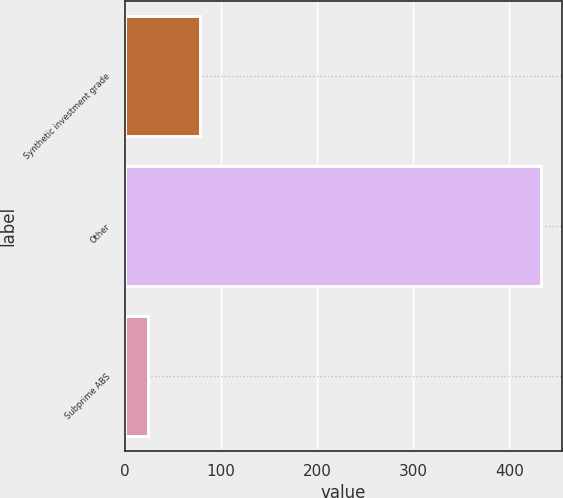Convert chart to OTSL. <chart><loc_0><loc_0><loc_500><loc_500><bar_chart><fcel>Synthetic investment grade<fcel>Other<fcel>Subprime ABS<nl><fcel>78<fcel>433<fcel>24<nl></chart> 